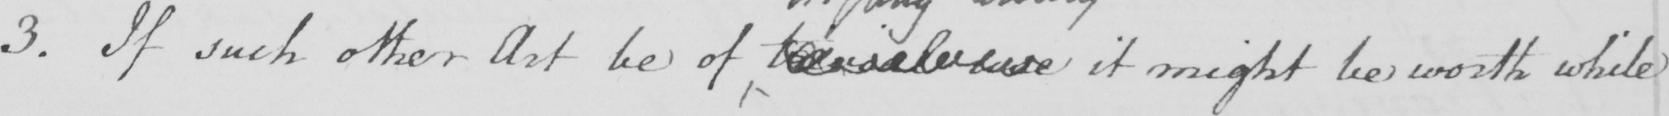What does this handwritten line say? 3 . If such other Art be of trivial use it might be worth while 